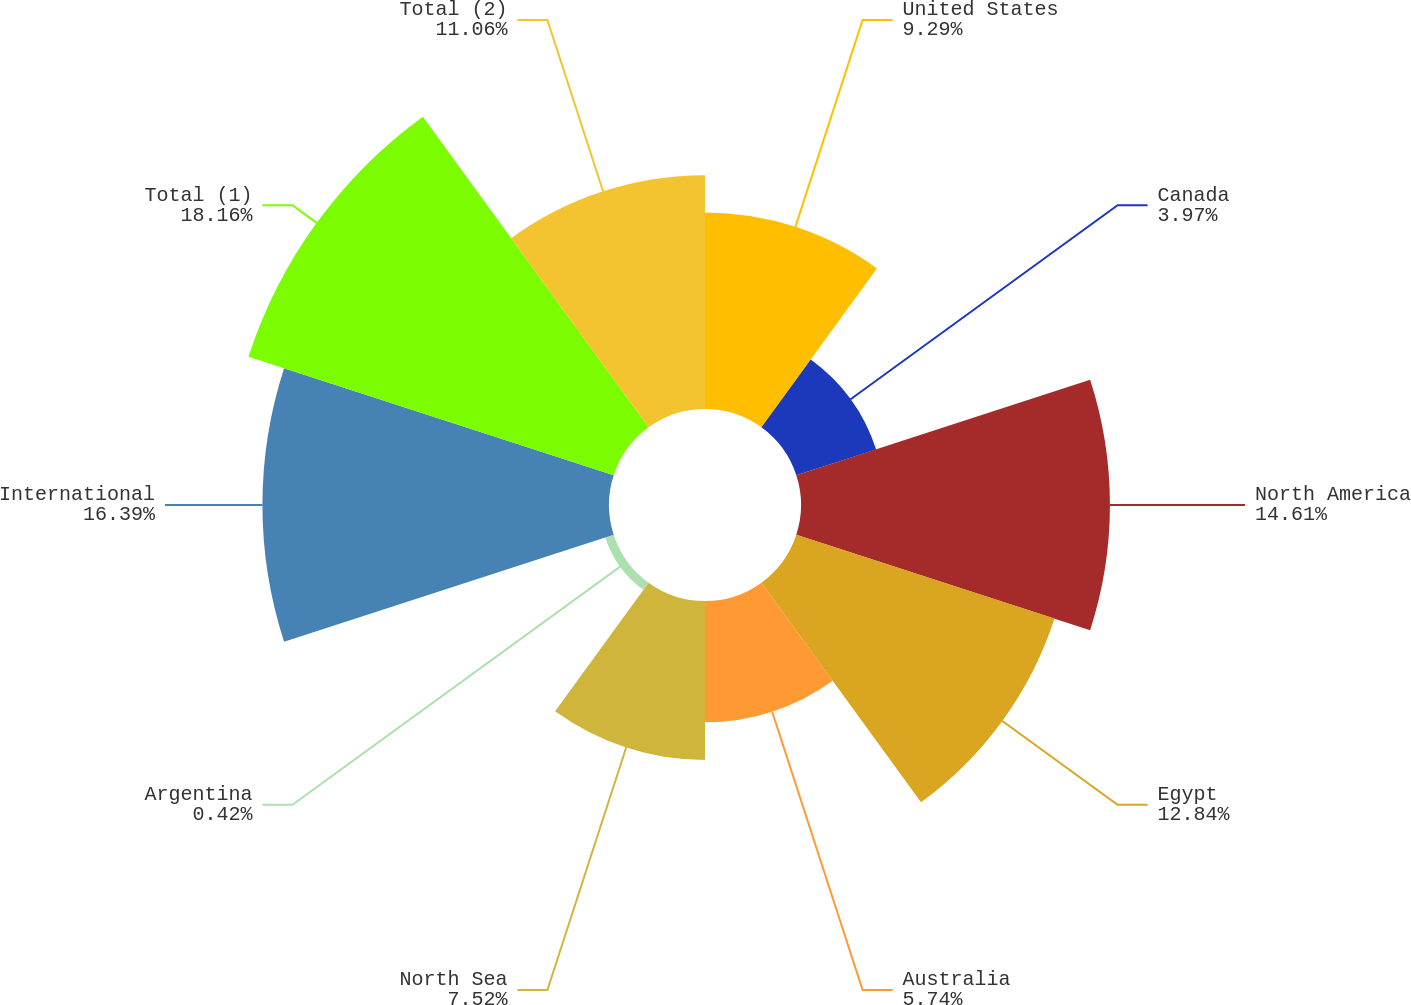Convert chart to OTSL. <chart><loc_0><loc_0><loc_500><loc_500><pie_chart><fcel>United States<fcel>Canada<fcel>North America<fcel>Egypt<fcel>Australia<fcel>North Sea<fcel>Argentina<fcel>International<fcel>Total (1)<fcel>Total (2)<nl><fcel>9.29%<fcel>3.97%<fcel>14.61%<fcel>12.84%<fcel>5.74%<fcel>7.52%<fcel>0.42%<fcel>16.39%<fcel>18.16%<fcel>11.06%<nl></chart> 